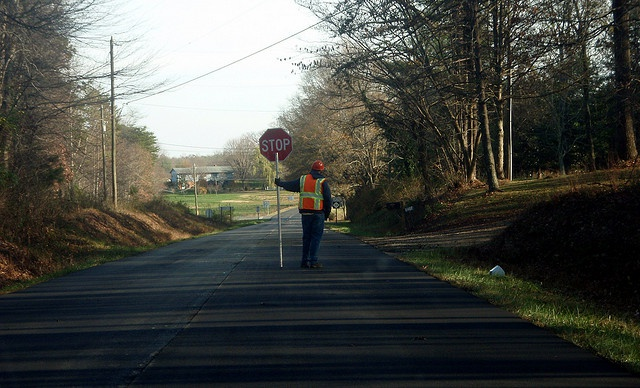Describe the objects in this image and their specific colors. I can see people in black, maroon, and gray tones and stop sign in black, maroon, and gray tones in this image. 